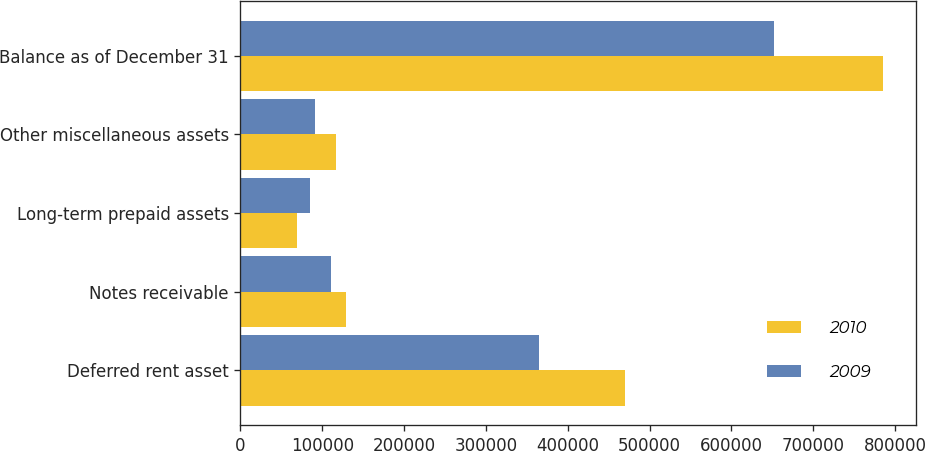Convert chart to OTSL. <chart><loc_0><loc_0><loc_500><loc_500><stacked_bar_chart><ecel><fcel>Deferred rent asset<fcel>Notes receivable<fcel>Long-term prepaid assets<fcel>Other miscellaneous assets<fcel>Balance as of December 31<nl><fcel>2010<fcel>470637<fcel>129157<fcel>69140<fcel>116940<fcel>785874<nl><fcel>2009<fcel>365112<fcel>110565<fcel>84801<fcel>91386<fcel>651864<nl></chart> 